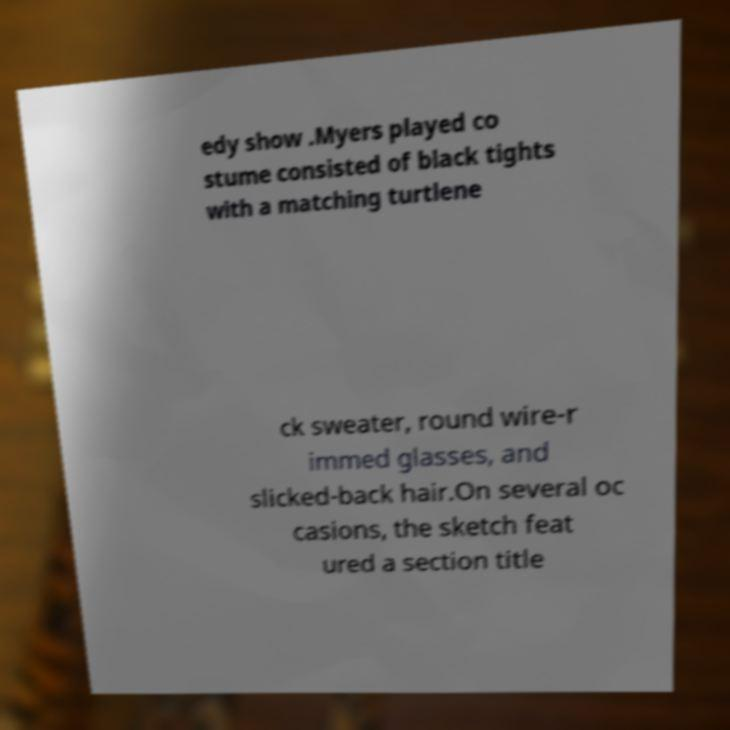Could you assist in decoding the text presented in this image and type it out clearly? edy show .Myers played co stume consisted of black tights with a matching turtlene ck sweater, round wire-r immed glasses, and slicked-back hair.On several oc casions, the sketch feat ured a section title 